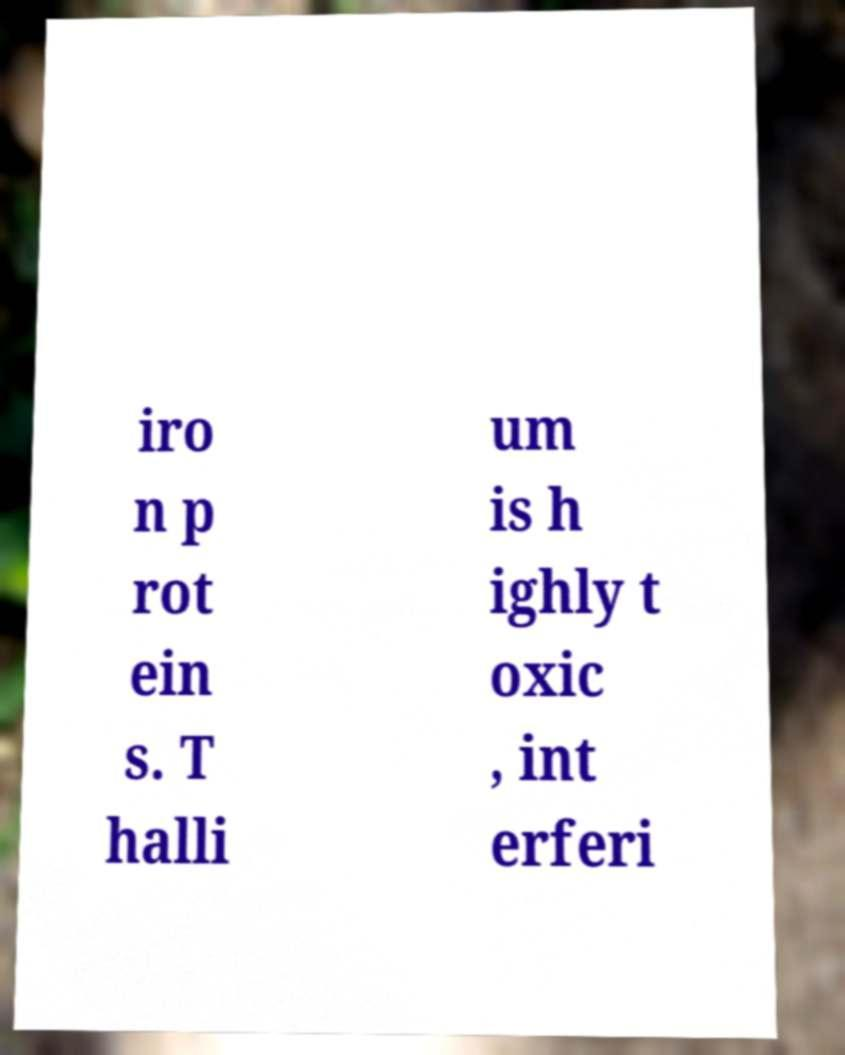I need the written content from this picture converted into text. Can you do that? iro n p rot ein s. T halli um is h ighly t oxic , int erferi 